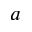Convert formula to latex. <formula><loc_0><loc_0><loc_500><loc_500>a</formula> 